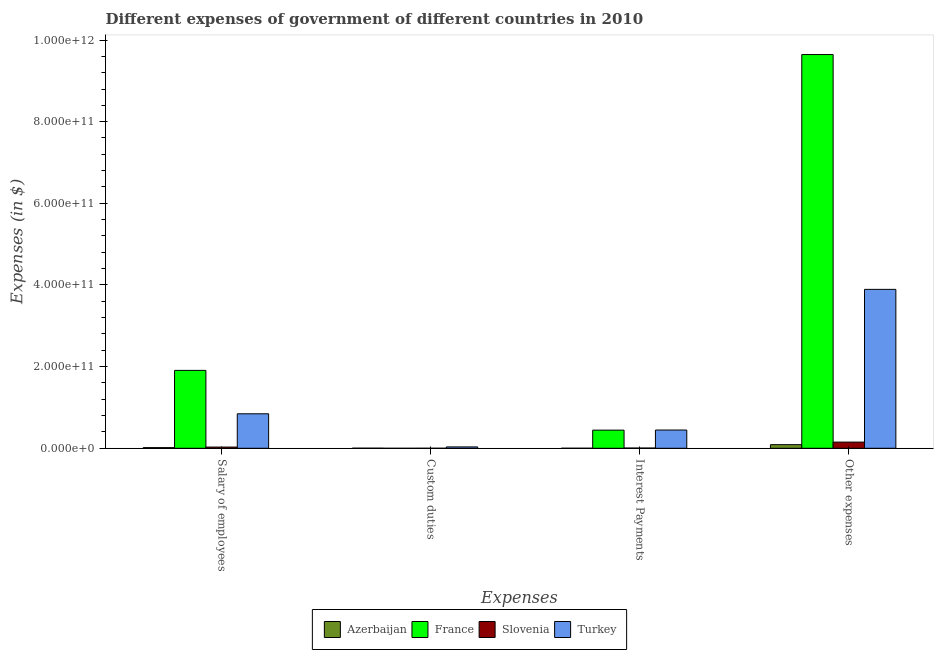Are the number of bars per tick equal to the number of legend labels?
Your answer should be very brief. No. What is the label of the 3rd group of bars from the left?
Keep it short and to the point. Interest Payments. What is the amount spent on custom duties in Slovenia?
Your answer should be very brief. 2.42e+07. Across all countries, what is the maximum amount spent on other expenses?
Offer a very short reply. 9.64e+11. Across all countries, what is the minimum amount spent on other expenses?
Your answer should be very brief. 8.86e+09. What is the total amount spent on custom duties in the graph?
Your answer should be very brief. 3.60e+09. What is the difference between the amount spent on interest payments in Slovenia and that in France?
Your answer should be compact. -4.39e+1. What is the difference between the amount spent on custom duties in France and the amount spent on interest payments in Turkey?
Your response must be concise. -4.47e+1. What is the average amount spent on other expenses per country?
Provide a succinct answer. 3.44e+11. What is the difference between the amount spent on salary of employees and amount spent on interest payments in Azerbaijan?
Offer a terse response. 1.55e+09. In how many countries, is the amount spent on custom duties greater than 440000000000 $?
Your answer should be compact. 0. What is the ratio of the amount spent on other expenses in Slovenia to that in Azerbaijan?
Your answer should be very brief. 1.71. What is the difference between the highest and the second highest amount spent on salary of employees?
Your response must be concise. 1.06e+11. What is the difference between the highest and the lowest amount spent on salary of employees?
Keep it short and to the point. 1.89e+11. Is the sum of the amount spent on interest payments in Azerbaijan and France greater than the maximum amount spent on salary of employees across all countries?
Provide a succinct answer. No. How many bars are there?
Ensure brevity in your answer.  15. How many countries are there in the graph?
Your answer should be very brief. 4. What is the difference between two consecutive major ticks on the Y-axis?
Your response must be concise. 2.00e+11. Does the graph contain any zero values?
Provide a short and direct response. Yes. Does the graph contain grids?
Your answer should be compact. No. What is the title of the graph?
Your answer should be compact. Different expenses of government of different countries in 2010. Does "St. Lucia" appear as one of the legend labels in the graph?
Offer a terse response. No. What is the label or title of the X-axis?
Offer a very short reply. Expenses. What is the label or title of the Y-axis?
Your response must be concise. Expenses (in $). What is the Expenses (in $) in Azerbaijan in Salary of employees?
Your response must be concise. 1.59e+09. What is the Expenses (in $) of France in Salary of employees?
Provide a succinct answer. 1.91e+11. What is the Expenses (in $) of Slovenia in Salary of employees?
Your answer should be very brief. 2.95e+09. What is the Expenses (in $) in Turkey in Salary of employees?
Offer a very short reply. 8.45e+1. What is the Expenses (in $) of Azerbaijan in Custom duties?
Your response must be concise. 2.18e+08. What is the Expenses (in $) of Slovenia in Custom duties?
Ensure brevity in your answer.  2.42e+07. What is the Expenses (in $) in Turkey in Custom duties?
Offer a terse response. 3.36e+09. What is the Expenses (in $) of Azerbaijan in Interest Payments?
Offer a very short reply. 3.95e+07. What is the Expenses (in $) of France in Interest Payments?
Make the answer very short. 4.45e+1. What is the Expenses (in $) in Slovenia in Interest Payments?
Give a very brief answer. 5.44e+08. What is the Expenses (in $) in Turkey in Interest Payments?
Your response must be concise. 4.47e+1. What is the Expenses (in $) of Azerbaijan in Other expenses?
Offer a very short reply. 8.86e+09. What is the Expenses (in $) in France in Other expenses?
Make the answer very short. 9.64e+11. What is the Expenses (in $) in Slovenia in Other expenses?
Keep it short and to the point. 1.51e+1. What is the Expenses (in $) in Turkey in Other expenses?
Provide a succinct answer. 3.89e+11. Across all Expenses, what is the maximum Expenses (in $) in Azerbaijan?
Your answer should be very brief. 8.86e+09. Across all Expenses, what is the maximum Expenses (in $) in France?
Provide a short and direct response. 9.64e+11. Across all Expenses, what is the maximum Expenses (in $) in Slovenia?
Provide a short and direct response. 1.51e+1. Across all Expenses, what is the maximum Expenses (in $) in Turkey?
Keep it short and to the point. 3.89e+11. Across all Expenses, what is the minimum Expenses (in $) of Azerbaijan?
Make the answer very short. 3.95e+07. Across all Expenses, what is the minimum Expenses (in $) of Slovenia?
Keep it short and to the point. 2.42e+07. Across all Expenses, what is the minimum Expenses (in $) of Turkey?
Offer a very short reply. 3.36e+09. What is the total Expenses (in $) of Azerbaijan in the graph?
Offer a very short reply. 1.07e+1. What is the total Expenses (in $) in France in the graph?
Ensure brevity in your answer.  1.20e+12. What is the total Expenses (in $) of Slovenia in the graph?
Ensure brevity in your answer.  1.86e+1. What is the total Expenses (in $) of Turkey in the graph?
Your answer should be compact. 5.22e+11. What is the difference between the Expenses (in $) in Azerbaijan in Salary of employees and that in Custom duties?
Offer a terse response. 1.37e+09. What is the difference between the Expenses (in $) in Slovenia in Salary of employees and that in Custom duties?
Your answer should be compact. 2.92e+09. What is the difference between the Expenses (in $) of Turkey in Salary of employees and that in Custom duties?
Your answer should be compact. 8.11e+1. What is the difference between the Expenses (in $) of Azerbaijan in Salary of employees and that in Interest Payments?
Provide a short and direct response. 1.55e+09. What is the difference between the Expenses (in $) in France in Salary of employees and that in Interest Payments?
Keep it short and to the point. 1.46e+11. What is the difference between the Expenses (in $) in Slovenia in Salary of employees and that in Interest Payments?
Your answer should be compact. 2.40e+09. What is the difference between the Expenses (in $) in Turkey in Salary of employees and that in Interest Payments?
Your response must be concise. 3.98e+1. What is the difference between the Expenses (in $) in Azerbaijan in Salary of employees and that in Other expenses?
Provide a succinct answer. -7.28e+09. What is the difference between the Expenses (in $) of France in Salary of employees and that in Other expenses?
Ensure brevity in your answer.  -7.74e+11. What is the difference between the Expenses (in $) in Slovenia in Salary of employees and that in Other expenses?
Make the answer very short. -1.22e+1. What is the difference between the Expenses (in $) of Turkey in Salary of employees and that in Other expenses?
Make the answer very short. -3.05e+11. What is the difference between the Expenses (in $) of Azerbaijan in Custom duties and that in Interest Payments?
Provide a short and direct response. 1.78e+08. What is the difference between the Expenses (in $) of Slovenia in Custom duties and that in Interest Payments?
Give a very brief answer. -5.20e+08. What is the difference between the Expenses (in $) of Turkey in Custom duties and that in Interest Payments?
Offer a very short reply. -4.13e+1. What is the difference between the Expenses (in $) of Azerbaijan in Custom duties and that in Other expenses?
Ensure brevity in your answer.  -8.65e+09. What is the difference between the Expenses (in $) of Slovenia in Custom duties and that in Other expenses?
Provide a short and direct response. -1.51e+1. What is the difference between the Expenses (in $) of Turkey in Custom duties and that in Other expenses?
Ensure brevity in your answer.  -3.86e+11. What is the difference between the Expenses (in $) in Azerbaijan in Interest Payments and that in Other expenses?
Your response must be concise. -8.82e+09. What is the difference between the Expenses (in $) of France in Interest Payments and that in Other expenses?
Make the answer very short. -9.20e+11. What is the difference between the Expenses (in $) of Slovenia in Interest Payments and that in Other expenses?
Offer a very short reply. -1.46e+1. What is the difference between the Expenses (in $) of Turkey in Interest Payments and that in Other expenses?
Ensure brevity in your answer.  -3.45e+11. What is the difference between the Expenses (in $) in Azerbaijan in Salary of employees and the Expenses (in $) in Slovenia in Custom duties?
Give a very brief answer. 1.56e+09. What is the difference between the Expenses (in $) of Azerbaijan in Salary of employees and the Expenses (in $) of Turkey in Custom duties?
Give a very brief answer. -1.77e+09. What is the difference between the Expenses (in $) in France in Salary of employees and the Expenses (in $) in Slovenia in Custom duties?
Give a very brief answer. 1.91e+11. What is the difference between the Expenses (in $) of France in Salary of employees and the Expenses (in $) of Turkey in Custom duties?
Ensure brevity in your answer.  1.87e+11. What is the difference between the Expenses (in $) of Slovenia in Salary of employees and the Expenses (in $) of Turkey in Custom duties?
Your answer should be very brief. -4.11e+08. What is the difference between the Expenses (in $) in Azerbaijan in Salary of employees and the Expenses (in $) in France in Interest Payments?
Your answer should be very brief. -4.29e+1. What is the difference between the Expenses (in $) of Azerbaijan in Salary of employees and the Expenses (in $) of Slovenia in Interest Payments?
Your answer should be compact. 1.04e+09. What is the difference between the Expenses (in $) in Azerbaijan in Salary of employees and the Expenses (in $) in Turkey in Interest Payments?
Your response must be concise. -4.31e+1. What is the difference between the Expenses (in $) of France in Salary of employees and the Expenses (in $) of Slovenia in Interest Payments?
Give a very brief answer. 1.90e+11. What is the difference between the Expenses (in $) in France in Salary of employees and the Expenses (in $) in Turkey in Interest Payments?
Provide a short and direct response. 1.46e+11. What is the difference between the Expenses (in $) in Slovenia in Salary of employees and the Expenses (in $) in Turkey in Interest Payments?
Make the answer very short. -4.18e+1. What is the difference between the Expenses (in $) in Azerbaijan in Salary of employees and the Expenses (in $) in France in Other expenses?
Make the answer very short. -9.63e+11. What is the difference between the Expenses (in $) in Azerbaijan in Salary of employees and the Expenses (in $) in Slovenia in Other expenses?
Your response must be concise. -1.35e+1. What is the difference between the Expenses (in $) of Azerbaijan in Salary of employees and the Expenses (in $) of Turkey in Other expenses?
Offer a very short reply. -3.88e+11. What is the difference between the Expenses (in $) of France in Salary of employees and the Expenses (in $) of Slovenia in Other expenses?
Make the answer very short. 1.76e+11. What is the difference between the Expenses (in $) of France in Salary of employees and the Expenses (in $) of Turkey in Other expenses?
Your answer should be very brief. -1.98e+11. What is the difference between the Expenses (in $) of Slovenia in Salary of employees and the Expenses (in $) of Turkey in Other expenses?
Provide a short and direct response. -3.86e+11. What is the difference between the Expenses (in $) in Azerbaijan in Custom duties and the Expenses (in $) in France in Interest Payments?
Keep it short and to the point. -4.42e+1. What is the difference between the Expenses (in $) in Azerbaijan in Custom duties and the Expenses (in $) in Slovenia in Interest Payments?
Offer a terse response. -3.27e+08. What is the difference between the Expenses (in $) in Azerbaijan in Custom duties and the Expenses (in $) in Turkey in Interest Payments?
Ensure brevity in your answer.  -4.45e+1. What is the difference between the Expenses (in $) in Slovenia in Custom duties and the Expenses (in $) in Turkey in Interest Payments?
Offer a very short reply. -4.47e+1. What is the difference between the Expenses (in $) of Azerbaijan in Custom duties and the Expenses (in $) of France in Other expenses?
Provide a succinct answer. -9.64e+11. What is the difference between the Expenses (in $) in Azerbaijan in Custom duties and the Expenses (in $) in Slovenia in Other expenses?
Keep it short and to the point. -1.49e+1. What is the difference between the Expenses (in $) of Azerbaijan in Custom duties and the Expenses (in $) of Turkey in Other expenses?
Keep it short and to the point. -3.89e+11. What is the difference between the Expenses (in $) of Slovenia in Custom duties and the Expenses (in $) of Turkey in Other expenses?
Your answer should be compact. -3.89e+11. What is the difference between the Expenses (in $) in Azerbaijan in Interest Payments and the Expenses (in $) in France in Other expenses?
Make the answer very short. -9.64e+11. What is the difference between the Expenses (in $) of Azerbaijan in Interest Payments and the Expenses (in $) of Slovenia in Other expenses?
Give a very brief answer. -1.51e+1. What is the difference between the Expenses (in $) of Azerbaijan in Interest Payments and the Expenses (in $) of Turkey in Other expenses?
Give a very brief answer. -3.89e+11. What is the difference between the Expenses (in $) in France in Interest Payments and the Expenses (in $) in Slovenia in Other expenses?
Your answer should be compact. 2.93e+1. What is the difference between the Expenses (in $) in France in Interest Payments and the Expenses (in $) in Turkey in Other expenses?
Your answer should be compact. -3.45e+11. What is the difference between the Expenses (in $) of Slovenia in Interest Payments and the Expenses (in $) of Turkey in Other expenses?
Provide a succinct answer. -3.89e+11. What is the average Expenses (in $) in Azerbaijan per Expenses?
Make the answer very short. 2.68e+09. What is the average Expenses (in $) of France per Expenses?
Give a very brief answer. 3.00e+11. What is the average Expenses (in $) in Slovenia per Expenses?
Ensure brevity in your answer.  4.66e+09. What is the average Expenses (in $) of Turkey per Expenses?
Offer a very short reply. 1.30e+11. What is the difference between the Expenses (in $) in Azerbaijan and Expenses (in $) in France in Salary of employees?
Give a very brief answer. -1.89e+11. What is the difference between the Expenses (in $) in Azerbaijan and Expenses (in $) in Slovenia in Salary of employees?
Your response must be concise. -1.36e+09. What is the difference between the Expenses (in $) in Azerbaijan and Expenses (in $) in Turkey in Salary of employees?
Provide a succinct answer. -8.29e+1. What is the difference between the Expenses (in $) of France and Expenses (in $) of Slovenia in Salary of employees?
Your answer should be compact. 1.88e+11. What is the difference between the Expenses (in $) in France and Expenses (in $) in Turkey in Salary of employees?
Your answer should be compact. 1.06e+11. What is the difference between the Expenses (in $) in Slovenia and Expenses (in $) in Turkey in Salary of employees?
Keep it short and to the point. -8.15e+1. What is the difference between the Expenses (in $) of Azerbaijan and Expenses (in $) of Slovenia in Custom duties?
Provide a short and direct response. 1.94e+08. What is the difference between the Expenses (in $) in Azerbaijan and Expenses (in $) in Turkey in Custom duties?
Make the answer very short. -3.14e+09. What is the difference between the Expenses (in $) in Slovenia and Expenses (in $) in Turkey in Custom duties?
Provide a succinct answer. -3.33e+09. What is the difference between the Expenses (in $) of Azerbaijan and Expenses (in $) of France in Interest Payments?
Make the answer very short. -4.44e+1. What is the difference between the Expenses (in $) of Azerbaijan and Expenses (in $) of Slovenia in Interest Payments?
Provide a succinct answer. -5.05e+08. What is the difference between the Expenses (in $) in Azerbaijan and Expenses (in $) in Turkey in Interest Payments?
Make the answer very short. -4.47e+1. What is the difference between the Expenses (in $) of France and Expenses (in $) of Slovenia in Interest Payments?
Your response must be concise. 4.39e+1. What is the difference between the Expenses (in $) of France and Expenses (in $) of Turkey in Interest Payments?
Offer a very short reply. -2.45e+08. What is the difference between the Expenses (in $) in Slovenia and Expenses (in $) in Turkey in Interest Payments?
Offer a very short reply. -4.42e+1. What is the difference between the Expenses (in $) in Azerbaijan and Expenses (in $) in France in Other expenses?
Provide a short and direct response. -9.56e+11. What is the difference between the Expenses (in $) in Azerbaijan and Expenses (in $) in Slovenia in Other expenses?
Make the answer very short. -6.25e+09. What is the difference between the Expenses (in $) in Azerbaijan and Expenses (in $) in Turkey in Other expenses?
Provide a short and direct response. -3.80e+11. What is the difference between the Expenses (in $) of France and Expenses (in $) of Slovenia in Other expenses?
Ensure brevity in your answer.  9.49e+11. What is the difference between the Expenses (in $) of France and Expenses (in $) of Turkey in Other expenses?
Give a very brief answer. 5.75e+11. What is the difference between the Expenses (in $) in Slovenia and Expenses (in $) in Turkey in Other expenses?
Ensure brevity in your answer.  -3.74e+11. What is the ratio of the Expenses (in $) in Azerbaijan in Salary of employees to that in Custom duties?
Your answer should be very brief. 7.29. What is the ratio of the Expenses (in $) of Slovenia in Salary of employees to that in Custom duties?
Your answer should be very brief. 121.86. What is the ratio of the Expenses (in $) of Turkey in Salary of employees to that in Custom duties?
Your answer should be compact. 25.16. What is the ratio of the Expenses (in $) of Azerbaijan in Salary of employees to that in Interest Payments?
Your answer should be very brief. 40.18. What is the ratio of the Expenses (in $) of France in Salary of employees to that in Interest Payments?
Your response must be concise. 4.29. What is the ratio of the Expenses (in $) in Slovenia in Salary of employees to that in Interest Payments?
Your response must be concise. 5.41. What is the ratio of the Expenses (in $) in Turkey in Salary of employees to that in Interest Payments?
Ensure brevity in your answer.  1.89. What is the ratio of the Expenses (in $) of Azerbaijan in Salary of employees to that in Other expenses?
Provide a succinct answer. 0.18. What is the ratio of the Expenses (in $) in France in Salary of employees to that in Other expenses?
Provide a succinct answer. 0.2. What is the ratio of the Expenses (in $) of Slovenia in Salary of employees to that in Other expenses?
Your answer should be compact. 0.19. What is the ratio of the Expenses (in $) in Turkey in Salary of employees to that in Other expenses?
Make the answer very short. 0.22. What is the ratio of the Expenses (in $) of Azerbaijan in Custom duties to that in Interest Payments?
Make the answer very short. 5.51. What is the ratio of the Expenses (in $) of Slovenia in Custom duties to that in Interest Payments?
Make the answer very short. 0.04. What is the ratio of the Expenses (in $) in Turkey in Custom duties to that in Interest Payments?
Your answer should be compact. 0.08. What is the ratio of the Expenses (in $) of Azerbaijan in Custom duties to that in Other expenses?
Your answer should be compact. 0.02. What is the ratio of the Expenses (in $) in Slovenia in Custom duties to that in Other expenses?
Your response must be concise. 0. What is the ratio of the Expenses (in $) in Turkey in Custom duties to that in Other expenses?
Your answer should be very brief. 0.01. What is the ratio of the Expenses (in $) of Azerbaijan in Interest Payments to that in Other expenses?
Your answer should be compact. 0. What is the ratio of the Expenses (in $) of France in Interest Payments to that in Other expenses?
Ensure brevity in your answer.  0.05. What is the ratio of the Expenses (in $) in Slovenia in Interest Payments to that in Other expenses?
Give a very brief answer. 0.04. What is the ratio of the Expenses (in $) in Turkey in Interest Payments to that in Other expenses?
Your answer should be compact. 0.11. What is the difference between the highest and the second highest Expenses (in $) in Azerbaijan?
Provide a succinct answer. 7.28e+09. What is the difference between the highest and the second highest Expenses (in $) of France?
Provide a short and direct response. 7.74e+11. What is the difference between the highest and the second highest Expenses (in $) in Slovenia?
Provide a succinct answer. 1.22e+1. What is the difference between the highest and the second highest Expenses (in $) in Turkey?
Provide a succinct answer. 3.05e+11. What is the difference between the highest and the lowest Expenses (in $) in Azerbaijan?
Provide a short and direct response. 8.82e+09. What is the difference between the highest and the lowest Expenses (in $) in France?
Provide a short and direct response. 9.64e+11. What is the difference between the highest and the lowest Expenses (in $) in Slovenia?
Make the answer very short. 1.51e+1. What is the difference between the highest and the lowest Expenses (in $) of Turkey?
Ensure brevity in your answer.  3.86e+11. 